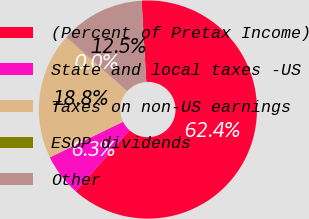Convert chart. <chart><loc_0><loc_0><loc_500><loc_500><pie_chart><fcel>(Percent of Pretax Income)<fcel>State and local taxes -US<fcel>Taxes on non-US earnings<fcel>ESOP dividends<fcel>Other<nl><fcel>62.43%<fcel>6.27%<fcel>18.75%<fcel>0.03%<fcel>12.51%<nl></chart> 